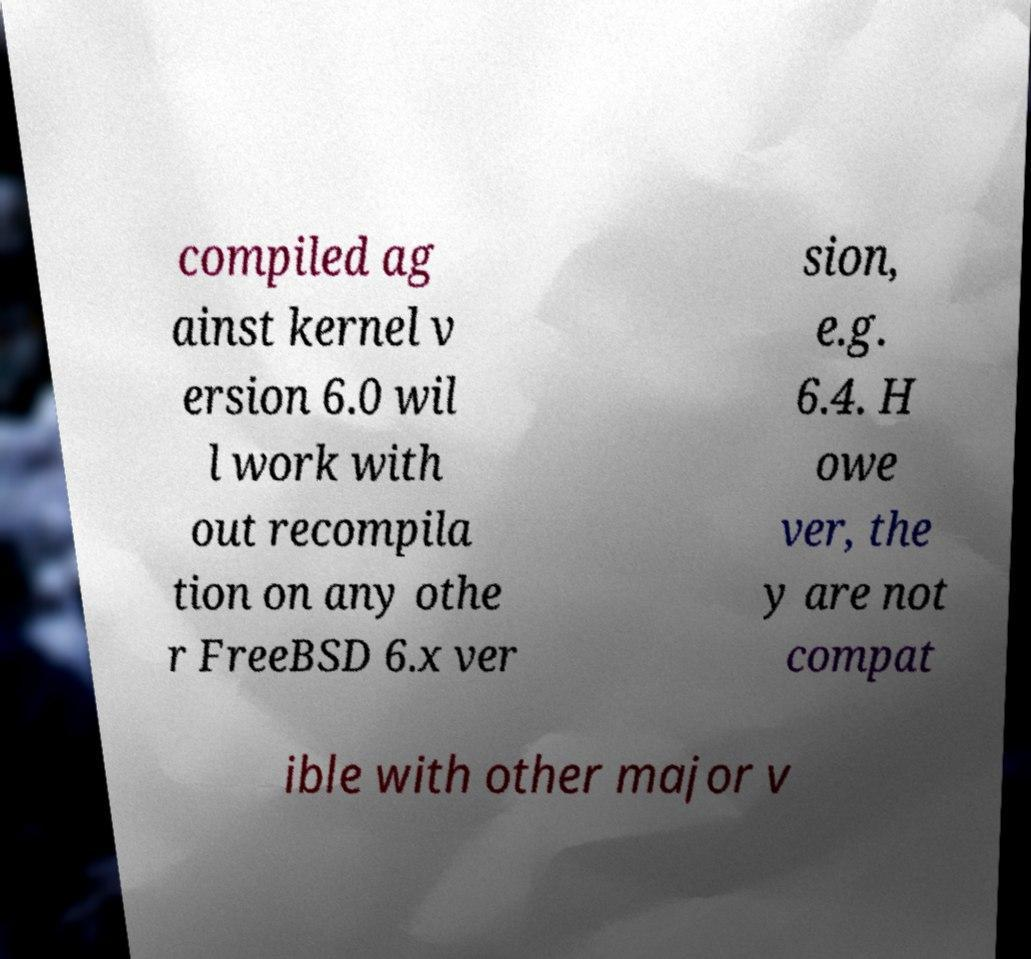There's text embedded in this image that I need extracted. Can you transcribe it verbatim? compiled ag ainst kernel v ersion 6.0 wil l work with out recompila tion on any othe r FreeBSD 6.x ver sion, e.g. 6.4. H owe ver, the y are not compat ible with other major v 